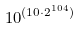Convert formula to latex. <formula><loc_0><loc_0><loc_500><loc_500>1 0 ^ { ( 1 0 \cdot 2 ^ { 1 0 4 } ) }</formula> 